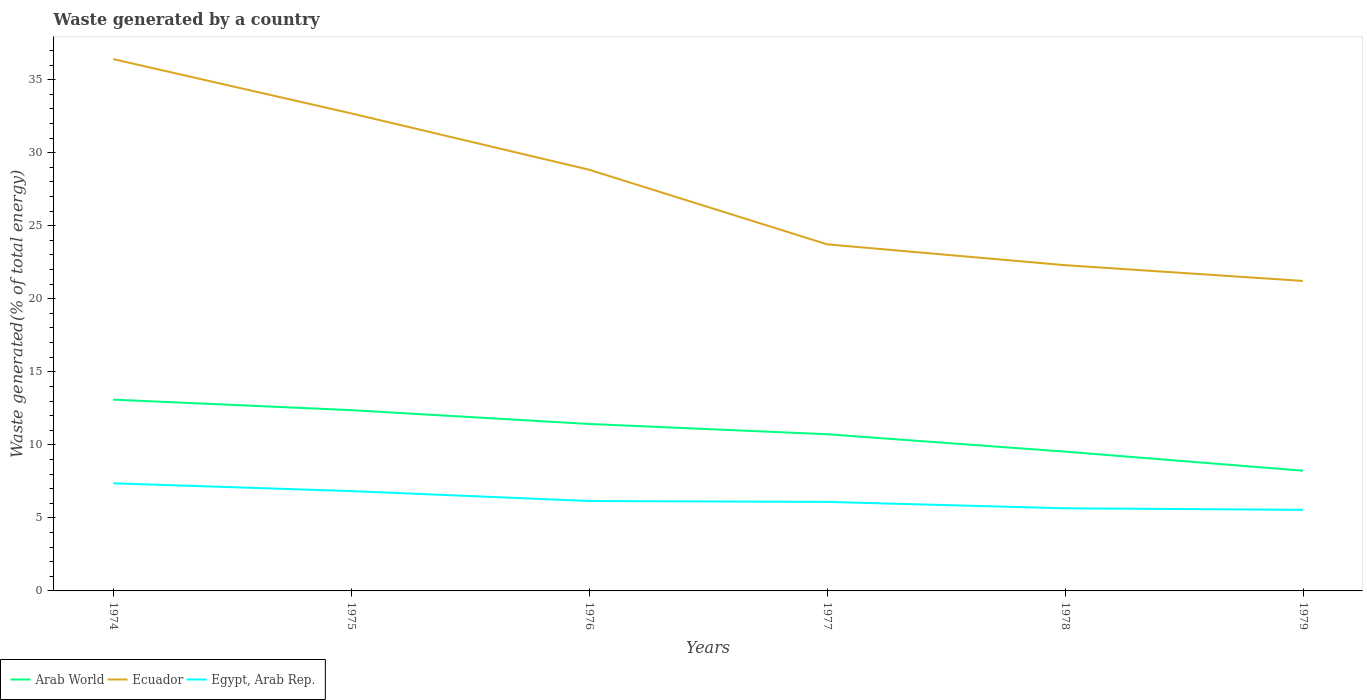Does the line corresponding to Arab World intersect with the line corresponding to Ecuador?
Make the answer very short. No. Across all years, what is the maximum total waste generated in Egypt, Arab Rep.?
Your response must be concise. 5.55. In which year was the total waste generated in Ecuador maximum?
Provide a succinct answer. 1979. What is the total total waste generated in Arab World in the graph?
Make the answer very short. 2.37. What is the difference between the highest and the second highest total waste generated in Ecuador?
Your answer should be very brief. 15.18. How many lines are there?
Keep it short and to the point. 3. How many years are there in the graph?
Ensure brevity in your answer.  6. Are the values on the major ticks of Y-axis written in scientific E-notation?
Offer a terse response. No. Does the graph contain any zero values?
Your answer should be compact. No. Does the graph contain grids?
Your answer should be compact. No. How many legend labels are there?
Offer a very short reply. 3. What is the title of the graph?
Ensure brevity in your answer.  Waste generated by a country. Does "Turkmenistan" appear as one of the legend labels in the graph?
Offer a very short reply. No. What is the label or title of the X-axis?
Your answer should be compact. Years. What is the label or title of the Y-axis?
Offer a very short reply. Waste generated(% of total energy). What is the Waste generated(% of total energy) in Arab World in 1974?
Make the answer very short. 13.09. What is the Waste generated(% of total energy) of Ecuador in 1974?
Make the answer very short. 36.41. What is the Waste generated(% of total energy) of Egypt, Arab Rep. in 1974?
Ensure brevity in your answer.  7.37. What is the Waste generated(% of total energy) of Arab World in 1975?
Make the answer very short. 12.38. What is the Waste generated(% of total energy) of Ecuador in 1975?
Your answer should be very brief. 32.69. What is the Waste generated(% of total energy) of Egypt, Arab Rep. in 1975?
Your answer should be very brief. 6.83. What is the Waste generated(% of total energy) of Arab World in 1976?
Give a very brief answer. 11.43. What is the Waste generated(% of total energy) in Ecuador in 1976?
Your response must be concise. 28.83. What is the Waste generated(% of total energy) in Egypt, Arab Rep. in 1976?
Keep it short and to the point. 6.16. What is the Waste generated(% of total energy) of Arab World in 1977?
Your answer should be compact. 10.73. What is the Waste generated(% of total energy) in Ecuador in 1977?
Your answer should be compact. 23.73. What is the Waste generated(% of total energy) of Egypt, Arab Rep. in 1977?
Your response must be concise. 6.09. What is the Waste generated(% of total energy) of Arab World in 1978?
Keep it short and to the point. 9.54. What is the Waste generated(% of total energy) in Ecuador in 1978?
Your response must be concise. 22.3. What is the Waste generated(% of total energy) of Egypt, Arab Rep. in 1978?
Give a very brief answer. 5.66. What is the Waste generated(% of total energy) of Arab World in 1979?
Your answer should be compact. 8.23. What is the Waste generated(% of total energy) in Ecuador in 1979?
Make the answer very short. 21.22. What is the Waste generated(% of total energy) of Egypt, Arab Rep. in 1979?
Give a very brief answer. 5.55. Across all years, what is the maximum Waste generated(% of total energy) in Arab World?
Provide a short and direct response. 13.09. Across all years, what is the maximum Waste generated(% of total energy) in Ecuador?
Your response must be concise. 36.41. Across all years, what is the maximum Waste generated(% of total energy) in Egypt, Arab Rep.?
Make the answer very short. 7.37. Across all years, what is the minimum Waste generated(% of total energy) of Arab World?
Keep it short and to the point. 8.23. Across all years, what is the minimum Waste generated(% of total energy) of Ecuador?
Give a very brief answer. 21.22. Across all years, what is the minimum Waste generated(% of total energy) in Egypt, Arab Rep.?
Provide a succinct answer. 5.55. What is the total Waste generated(% of total energy) of Arab World in the graph?
Keep it short and to the point. 65.39. What is the total Waste generated(% of total energy) in Ecuador in the graph?
Your response must be concise. 165.18. What is the total Waste generated(% of total energy) of Egypt, Arab Rep. in the graph?
Provide a short and direct response. 37.66. What is the difference between the Waste generated(% of total energy) of Arab World in 1974 and that in 1975?
Offer a terse response. 0.72. What is the difference between the Waste generated(% of total energy) of Ecuador in 1974 and that in 1975?
Keep it short and to the point. 3.71. What is the difference between the Waste generated(% of total energy) in Egypt, Arab Rep. in 1974 and that in 1975?
Your answer should be very brief. 0.53. What is the difference between the Waste generated(% of total energy) of Arab World in 1974 and that in 1976?
Provide a succinct answer. 1.67. What is the difference between the Waste generated(% of total energy) in Ecuador in 1974 and that in 1976?
Provide a succinct answer. 7.57. What is the difference between the Waste generated(% of total energy) in Egypt, Arab Rep. in 1974 and that in 1976?
Give a very brief answer. 1.21. What is the difference between the Waste generated(% of total energy) in Arab World in 1974 and that in 1977?
Offer a very short reply. 2.37. What is the difference between the Waste generated(% of total energy) in Ecuador in 1974 and that in 1977?
Ensure brevity in your answer.  12.68. What is the difference between the Waste generated(% of total energy) of Egypt, Arab Rep. in 1974 and that in 1977?
Your answer should be compact. 1.27. What is the difference between the Waste generated(% of total energy) in Arab World in 1974 and that in 1978?
Your response must be concise. 3.56. What is the difference between the Waste generated(% of total energy) of Ecuador in 1974 and that in 1978?
Provide a succinct answer. 14.11. What is the difference between the Waste generated(% of total energy) in Egypt, Arab Rep. in 1974 and that in 1978?
Offer a terse response. 1.71. What is the difference between the Waste generated(% of total energy) of Arab World in 1974 and that in 1979?
Your answer should be very brief. 4.87. What is the difference between the Waste generated(% of total energy) in Ecuador in 1974 and that in 1979?
Offer a very short reply. 15.18. What is the difference between the Waste generated(% of total energy) in Egypt, Arab Rep. in 1974 and that in 1979?
Offer a terse response. 1.82. What is the difference between the Waste generated(% of total energy) of Arab World in 1975 and that in 1976?
Your answer should be very brief. 0.95. What is the difference between the Waste generated(% of total energy) of Ecuador in 1975 and that in 1976?
Make the answer very short. 3.86. What is the difference between the Waste generated(% of total energy) of Egypt, Arab Rep. in 1975 and that in 1976?
Ensure brevity in your answer.  0.68. What is the difference between the Waste generated(% of total energy) of Arab World in 1975 and that in 1977?
Make the answer very short. 1.65. What is the difference between the Waste generated(% of total energy) of Ecuador in 1975 and that in 1977?
Your answer should be very brief. 8.97. What is the difference between the Waste generated(% of total energy) of Egypt, Arab Rep. in 1975 and that in 1977?
Provide a short and direct response. 0.74. What is the difference between the Waste generated(% of total energy) of Arab World in 1975 and that in 1978?
Make the answer very short. 2.84. What is the difference between the Waste generated(% of total energy) in Ecuador in 1975 and that in 1978?
Your answer should be compact. 10.39. What is the difference between the Waste generated(% of total energy) in Egypt, Arab Rep. in 1975 and that in 1978?
Give a very brief answer. 1.18. What is the difference between the Waste generated(% of total energy) in Arab World in 1975 and that in 1979?
Your answer should be very brief. 4.15. What is the difference between the Waste generated(% of total energy) of Ecuador in 1975 and that in 1979?
Keep it short and to the point. 11.47. What is the difference between the Waste generated(% of total energy) of Egypt, Arab Rep. in 1975 and that in 1979?
Your answer should be compact. 1.28. What is the difference between the Waste generated(% of total energy) in Arab World in 1976 and that in 1977?
Keep it short and to the point. 0.7. What is the difference between the Waste generated(% of total energy) of Ecuador in 1976 and that in 1977?
Give a very brief answer. 5.11. What is the difference between the Waste generated(% of total energy) of Egypt, Arab Rep. in 1976 and that in 1977?
Offer a very short reply. 0.06. What is the difference between the Waste generated(% of total energy) of Arab World in 1976 and that in 1978?
Make the answer very short. 1.89. What is the difference between the Waste generated(% of total energy) of Ecuador in 1976 and that in 1978?
Provide a short and direct response. 6.53. What is the difference between the Waste generated(% of total energy) in Egypt, Arab Rep. in 1976 and that in 1978?
Provide a short and direct response. 0.5. What is the difference between the Waste generated(% of total energy) of Arab World in 1976 and that in 1979?
Give a very brief answer. 3.2. What is the difference between the Waste generated(% of total energy) in Ecuador in 1976 and that in 1979?
Keep it short and to the point. 7.61. What is the difference between the Waste generated(% of total energy) in Egypt, Arab Rep. in 1976 and that in 1979?
Offer a terse response. 0.6. What is the difference between the Waste generated(% of total energy) in Arab World in 1977 and that in 1978?
Offer a terse response. 1.19. What is the difference between the Waste generated(% of total energy) of Ecuador in 1977 and that in 1978?
Offer a terse response. 1.43. What is the difference between the Waste generated(% of total energy) in Egypt, Arab Rep. in 1977 and that in 1978?
Give a very brief answer. 0.44. What is the difference between the Waste generated(% of total energy) in Arab World in 1977 and that in 1979?
Offer a terse response. 2.5. What is the difference between the Waste generated(% of total energy) in Ecuador in 1977 and that in 1979?
Keep it short and to the point. 2.5. What is the difference between the Waste generated(% of total energy) of Egypt, Arab Rep. in 1977 and that in 1979?
Your answer should be very brief. 0.54. What is the difference between the Waste generated(% of total energy) of Arab World in 1978 and that in 1979?
Provide a short and direct response. 1.31. What is the difference between the Waste generated(% of total energy) in Ecuador in 1978 and that in 1979?
Your response must be concise. 1.08. What is the difference between the Waste generated(% of total energy) of Egypt, Arab Rep. in 1978 and that in 1979?
Make the answer very short. 0.1. What is the difference between the Waste generated(% of total energy) of Arab World in 1974 and the Waste generated(% of total energy) of Ecuador in 1975?
Your answer should be compact. -19.6. What is the difference between the Waste generated(% of total energy) in Arab World in 1974 and the Waste generated(% of total energy) in Egypt, Arab Rep. in 1975?
Provide a succinct answer. 6.26. What is the difference between the Waste generated(% of total energy) of Ecuador in 1974 and the Waste generated(% of total energy) of Egypt, Arab Rep. in 1975?
Provide a short and direct response. 29.57. What is the difference between the Waste generated(% of total energy) in Arab World in 1974 and the Waste generated(% of total energy) in Ecuador in 1976?
Your answer should be compact. -15.74. What is the difference between the Waste generated(% of total energy) in Arab World in 1974 and the Waste generated(% of total energy) in Egypt, Arab Rep. in 1976?
Keep it short and to the point. 6.94. What is the difference between the Waste generated(% of total energy) of Ecuador in 1974 and the Waste generated(% of total energy) of Egypt, Arab Rep. in 1976?
Provide a short and direct response. 30.25. What is the difference between the Waste generated(% of total energy) of Arab World in 1974 and the Waste generated(% of total energy) of Ecuador in 1977?
Keep it short and to the point. -10.63. What is the difference between the Waste generated(% of total energy) in Arab World in 1974 and the Waste generated(% of total energy) in Egypt, Arab Rep. in 1977?
Your answer should be very brief. 7. What is the difference between the Waste generated(% of total energy) of Ecuador in 1974 and the Waste generated(% of total energy) of Egypt, Arab Rep. in 1977?
Make the answer very short. 30.31. What is the difference between the Waste generated(% of total energy) in Arab World in 1974 and the Waste generated(% of total energy) in Ecuador in 1978?
Provide a short and direct response. -9.21. What is the difference between the Waste generated(% of total energy) in Arab World in 1974 and the Waste generated(% of total energy) in Egypt, Arab Rep. in 1978?
Make the answer very short. 7.44. What is the difference between the Waste generated(% of total energy) of Ecuador in 1974 and the Waste generated(% of total energy) of Egypt, Arab Rep. in 1978?
Provide a succinct answer. 30.75. What is the difference between the Waste generated(% of total energy) in Arab World in 1974 and the Waste generated(% of total energy) in Ecuador in 1979?
Your response must be concise. -8.13. What is the difference between the Waste generated(% of total energy) of Arab World in 1974 and the Waste generated(% of total energy) of Egypt, Arab Rep. in 1979?
Offer a very short reply. 7.54. What is the difference between the Waste generated(% of total energy) of Ecuador in 1974 and the Waste generated(% of total energy) of Egypt, Arab Rep. in 1979?
Keep it short and to the point. 30.86. What is the difference between the Waste generated(% of total energy) in Arab World in 1975 and the Waste generated(% of total energy) in Ecuador in 1976?
Your response must be concise. -16.46. What is the difference between the Waste generated(% of total energy) of Arab World in 1975 and the Waste generated(% of total energy) of Egypt, Arab Rep. in 1976?
Provide a succinct answer. 6.22. What is the difference between the Waste generated(% of total energy) in Ecuador in 1975 and the Waste generated(% of total energy) in Egypt, Arab Rep. in 1976?
Offer a terse response. 26.54. What is the difference between the Waste generated(% of total energy) in Arab World in 1975 and the Waste generated(% of total energy) in Ecuador in 1977?
Offer a terse response. -11.35. What is the difference between the Waste generated(% of total energy) of Arab World in 1975 and the Waste generated(% of total energy) of Egypt, Arab Rep. in 1977?
Your answer should be compact. 6.28. What is the difference between the Waste generated(% of total energy) of Ecuador in 1975 and the Waste generated(% of total energy) of Egypt, Arab Rep. in 1977?
Ensure brevity in your answer.  26.6. What is the difference between the Waste generated(% of total energy) in Arab World in 1975 and the Waste generated(% of total energy) in Ecuador in 1978?
Your answer should be compact. -9.92. What is the difference between the Waste generated(% of total energy) of Arab World in 1975 and the Waste generated(% of total energy) of Egypt, Arab Rep. in 1978?
Offer a very short reply. 6.72. What is the difference between the Waste generated(% of total energy) in Ecuador in 1975 and the Waste generated(% of total energy) in Egypt, Arab Rep. in 1978?
Give a very brief answer. 27.04. What is the difference between the Waste generated(% of total energy) of Arab World in 1975 and the Waste generated(% of total energy) of Ecuador in 1979?
Your answer should be very brief. -8.85. What is the difference between the Waste generated(% of total energy) of Arab World in 1975 and the Waste generated(% of total energy) of Egypt, Arab Rep. in 1979?
Keep it short and to the point. 6.82. What is the difference between the Waste generated(% of total energy) in Ecuador in 1975 and the Waste generated(% of total energy) in Egypt, Arab Rep. in 1979?
Offer a terse response. 27.14. What is the difference between the Waste generated(% of total energy) of Arab World in 1976 and the Waste generated(% of total energy) of Ecuador in 1977?
Offer a terse response. -12.3. What is the difference between the Waste generated(% of total energy) of Arab World in 1976 and the Waste generated(% of total energy) of Egypt, Arab Rep. in 1977?
Your answer should be very brief. 5.33. What is the difference between the Waste generated(% of total energy) of Ecuador in 1976 and the Waste generated(% of total energy) of Egypt, Arab Rep. in 1977?
Your answer should be very brief. 22.74. What is the difference between the Waste generated(% of total energy) in Arab World in 1976 and the Waste generated(% of total energy) in Ecuador in 1978?
Provide a succinct answer. -10.87. What is the difference between the Waste generated(% of total energy) of Arab World in 1976 and the Waste generated(% of total energy) of Egypt, Arab Rep. in 1978?
Make the answer very short. 5.77. What is the difference between the Waste generated(% of total energy) of Ecuador in 1976 and the Waste generated(% of total energy) of Egypt, Arab Rep. in 1978?
Ensure brevity in your answer.  23.18. What is the difference between the Waste generated(% of total energy) of Arab World in 1976 and the Waste generated(% of total energy) of Ecuador in 1979?
Your answer should be very brief. -9.79. What is the difference between the Waste generated(% of total energy) of Arab World in 1976 and the Waste generated(% of total energy) of Egypt, Arab Rep. in 1979?
Ensure brevity in your answer.  5.88. What is the difference between the Waste generated(% of total energy) of Ecuador in 1976 and the Waste generated(% of total energy) of Egypt, Arab Rep. in 1979?
Your answer should be compact. 23.28. What is the difference between the Waste generated(% of total energy) of Arab World in 1977 and the Waste generated(% of total energy) of Ecuador in 1978?
Keep it short and to the point. -11.57. What is the difference between the Waste generated(% of total energy) of Arab World in 1977 and the Waste generated(% of total energy) of Egypt, Arab Rep. in 1978?
Keep it short and to the point. 5.07. What is the difference between the Waste generated(% of total energy) of Ecuador in 1977 and the Waste generated(% of total energy) of Egypt, Arab Rep. in 1978?
Ensure brevity in your answer.  18.07. What is the difference between the Waste generated(% of total energy) of Arab World in 1977 and the Waste generated(% of total energy) of Ecuador in 1979?
Keep it short and to the point. -10.5. What is the difference between the Waste generated(% of total energy) of Arab World in 1977 and the Waste generated(% of total energy) of Egypt, Arab Rep. in 1979?
Your answer should be very brief. 5.18. What is the difference between the Waste generated(% of total energy) of Ecuador in 1977 and the Waste generated(% of total energy) of Egypt, Arab Rep. in 1979?
Offer a very short reply. 18.18. What is the difference between the Waste generated(% of total energy) of Arab World in 1978 and the Waste generated(% of total energy) of Ecuador in 1979?
Ensure brevity in your answer.  -11.69. What is the difference between the Waste generated(% of total energy) of Arab World in 1978 and the Waste generated(% of total energy) of Egypt, Arab Rep. in 1979?
Offer a very short reply. 3.98. What is the difference between the Waste generated(% of total energy) in Ecuador in 1978 and the Waste generated(% of total energy) in Egypt, Arab Rep. in 1979?
Provide a short and direct response. 16.75. What is the average Waste generated(% of total energy) in Arab World per year?
Make the answer very short. 10.9. What is the average Waste generated(% of total energy) in Ecuador per year?
Offer a very short reply. 27.53. What is the average Waste generated(% of total energy) of Egypt, Arab Rep. per year?
Ensure brevity in your answer.  6.28. In the year 1974, what is the difference between the Waste generated(% of total energy) of Arab World and Waste generated(% of total energy) of Ecuador?
Give a very brief answer. -23.31. In the year 1974, what is the difference between the Waste generated(% of total energy) of Arab World and Waste generated(% of total energy) of Egypt, Arab Rep.?
Offer a very short reply. 5.73. In the year 1974, what is the difference between the Waste generated(% of total energy) in Ecuador and Waste generated(% of total energy) in Egypt, Arab Rep.?
Make the answer very short. 29.04. In the year 1975, what is the difference between the Waste generated(% of total energy) in Arab World and Waste generated(% of total energy) in Ecuador?
Provide a succinct answer. -20.32. In the year 1975, what is the difference between the Waste generated(% of total energy) in Arab World and Waste generated(% of total energy) in Egypt, Arab Rep.?
Offer a terse response. 5.54. In the year 1975, what is the difference between the Waste generated(% of total energy) of Ecuador and Waste generated(% of total energy) of Egypt, Arab Rep.?
Provide a short and direct response. 25.86. In the year 1976, what is the difference between the Waste generated(% of total energy) of Arab World and Waste generated(% of total energy) of Ecuador?
Keep it short and to the point. -17.41. In the year 1976, what is the difference between the Waste generated(% of total energy) of Arab World and Waste generated(% of total energy) of Egypt, Arab Rep.?
Your answer should be compact. 5.27. In the year 1976, what is the difference between the Waste generated(% of total energy) of Ecuador and Waste generated(% of total energy) of Egypt, Arab Rep.?
Provide a succinct answer. 22.68. In the year 1977, what is the difference between the Waste generated(% of total energy) of Arab World and Waste generated(% of total energy) of Ecuador?
Your answer should be compact. -13. In the year 1977, what is the difference between the Waste generated(% of total energy) of Arab World and Waste generated(% of total energy) of Egypt, Arab Rep.?
Make the answer very short. 4.63. In the year 1977, what is the difference between the Waste generated(% of total energy) of Ecuador and Waste generated(% of total energy) of Egypt, Arab Rep.?
Your response must be concise. 17.63. In the year 1978, what is the difference between the Waste generated(% of total energy) in Arab World and Waste generated(% of total energy) in Ecuador?
Offer a terse response. -12.76. In the year 1978, what is the difference between the Waste generated(% of total energy) of Arab World and Waste generated(% of total energy) of Egypt, Arab Rep.?
Your answer should be compact. 3.88. In the year 1978, what is the difference between the Waste generated(% of total energy) in Ecuador and Waste generated(% of total energy) in Egypt, Arab Rep.?
Keep it short and to the point. 16.64. In the year 1979, what is the difference between the Waste generated(% of total energy) of Arab World and Waste generated(% of total energy) of Ecuador?
Offer a terse response. -12.99. In the year 1979, what is the difference between the Waste generated(% of total energy) of Arab World and Waste generated(% of total energy) of Egypt, Arab Rep.?
Offer a very short reply. 2.68. In the year 1979, what is the difference between the Waste generated(% of total energy) of Ecuador and Waste generated(% of total energy) of Egypt, Arab Rep.?
Ensure brevity in your answer.  15.67. What is the ratio of the Waste generated(% of total energy) of Arab World in 1974 to that in 1975?
Your answer should be very brief. 1.06. What is the ratio of the Waste generated(% of total energy) of Ecuador in 1974 to that in 1975?
Your answer should be compact. 1.11. What is the ratio of the Waste generated(% of total energy) in Egypt, Arab Rep. in 1974 to that in 1975?
Provide a succinct answer. 1.08. What is the ratio of the Waste generated(% of total energy) in Arab World in 1974 to that in 1976?
Offer a terse response. 1.15. What is the ratio of the Waste generated(% of total energy) of Ecuador in 1974 to that in 1976?
Provide a short and direct response. 1.26. What is the ratio of the Waste generated(% of total energy) of Egypt, Arab Rep. in 1974 to that in 1976?
Offer a very short reply. 1.2. What is the ratio of the Waste generated(% of total energy) of Arab World in 1974 to that in 1977?
Your answer should be compact. 1.22. What is the ratio of the Waste generated(% of total energy) in Ecuador in 1974 to that in 1977?
Your answer should be very brief. 1.53. What is the ratio of the Waste generated(% of total energy) of Egypt, Arab Rep. in 1974 to that in 1977?
Your response must be concise. 1.21. What is the ratio of the Waste generated(% of total energy) of Arab World in 1974 to that in 1978?
Your response must be concise. 1.37. What is the ratio of the Waste generated(% of total energy) in Ecuador in 1974 to that in 1978?
Ensure brevity in your answer.  1.63. What is the ratio of the Waste generated(% of total energy) of Egypt, Arab Rep. in 1974 to that in 1978?
Ensure brevity in your answer.  1.3. What is the ratio of the Waste generated(% of total energy) of Arab World in 1974 to that in 1979?
Offer a very short reply. 1.59. What is the ratio of the Waste generated(% of total energy) of Ecuador in 1974 to that in 1979?
Your answer should be compact. 1.72. What is the ratio of the Waste generated(% of total energy) in Egypt, Arab Rep. in 1974 to that in 1979?
Make the answer very short. 1.33. What is the ratio of the Waste generated(% of total energy) in Arab World in 1975 to that in 1976?
Provide a succinct answer. 1.08. What is the ratio of the Waste generated(% of total energy) of Ecuador in 1975 to that in 1976?
Your answer should be very brief. 1.13. What is the ratio of the Waste generated(% of total energy) of Egypt, Arab Rep. in 1975 to that in 1976?
Provide a succinct answer. 1.11. What is the ratio of the Waste generated(% of total energy) of Arab World in 1975 to that in 1977?
Ensure brevity in your answer.  1.15. What is the ratio of the Waste generated(% of total energy) of Ecuador in 1975 to that in 1977?
Provide a short and direct response. 1.38. What is the ratio of the Waste generated(% of total energy) in Egypt, Arab Rep. in 1975 to that in 1977?
Ensure brevity in your answer.  1.12. What is the ratio of the Waste generated(% of total energy) of Arab World in 1975 to that in 1978?
Provide a succinct answer. 1.3. What is the ratio of the Waste generated(% of total energy) in Ecuador in 1975 to that in 1978?
Give a very brief answer. 1.47. What is the ratio of the Waste generated(% of total energy) in Egypt, Arab Rep. in 1975 to that in 1978?
Provide a short and direct response. 1.21. What is the ratio of the Waste generated(% of total energy) of Arab World in 1975 to that in 1979?
Provide a succinct answer. 1.5. What is the ratio of the Waste generated(% of total energy) in Ecuador in 1975 to that in 1979?
Make the answer very short. 1.54. What is the ratio of the Waste generated(% of total energy) of Egypt, Arab Rep. in 1975 to that in 1979?
Give a very brief answer. 1.23. What is the ratio of the Waste generated(% of total energy) of Arab World in 1976 to that in 1977?
Your answer should be very brief. 1.07. What is the ratio of the Waste generated(% of total energy) in Ecuador in 1976 to that in 1977?
Ensure brevity in your answer.  1.22. What is the ratio of the Waste generated(% of total energy) of Egypt, Arab Rep. in 1976 to that in 1977?
Offer a very short reply. 1.01. What is the ratio of the Waste generated(% of total energy) of Arab World in 1976 to that in 1978?
Provide a succinct answer. 1.2. What is the ratio of the Waste generated(% of total energy) in Ecuador in 1976 to that in 1978?
Your answer should be very brief. 1.29. What is the ratio of the Waste generated(% of total energy) in Egypt, Arab Rep. in 1976 to that in 1978?
Provide a succinct answer. 1.09. What is the ratio of the Waste generated(% of total energy) in Arab World in 1976 to that in 1979?
Your response must be concise. 1.39. What is the ratio of the Waste generated(% of total energy) of Ecuador in 1976 to that in 1979?
Offer a very short reply. 1.36. What is the ratio of the Waste generated(% of total energy) of Egypt, Arab Rep. in 1976 to that in 1979?
Ensure brevity in your answer.  1.11. What is the ratio of the Waste generated(% of total energy) of Arab World in 1977 to that in 1978?
Give a very brief answer. 1.12. What is the ratio of the Waste generated(% of total energy) in Ecuador in 1977 to that in 1978?
Your answer should be compact. 1.06. What is the ratio of the Waste generated(% of total energy) in Egypt, Arab Rep. in 1977 to that in 1978?
Ensure brevity in your answer.  1.08. What is the ratio of the Waste generated(% of total energy) of Arab World in 1977 to that in 1979?
Make the answer very short. 1.3. What is the ratio of the Waste generated(% of total energy) of Ecuador in 1977 to that in 1979?
Offer a very short reply. 1.12. What is the ratio of the Waste generated(% of total energy) in Egypt, Arab Rep. in 1977 to that in 1979?
Ensure brevity in your answer.  1.1. What is the ratio of the Waste generated(% of total energy) in Arab World in 1978 to that in 1979?
Provide a short and direct response. 1.16. What is the ratio of the Waste generated(% of total energy) of Ecuador in 1978 to that in 1979?
Keep it short and to the point. 1.05. What is the ratio of the Waste generated(% of total energy) of Egypt, Arab Rep. in 1978 to that in 1979?
Provide a short and direct response. 1.02. What is the difference between the highest and the second highest Waste generated(% of total energy) of Arab World?
Your answer should be compact. 0.72. What is the difference between the highest and the second highest Waste generated(% of total energy) of Ecuador?
Ensure brevity in your answer.  3.71. What is the difference between the highest and the second highest Waste generated(% of total energy) of Egypt, Arab Rep.?
Make the answer very short. 0.53. What is the difference between the highest and the lowest Waste generated(% of total energy) of Arab World?
Give a very brief answer. 4.87. What is the difference between the highest and the lowest Waste generated(% of total energy) of Ecuador?
Make the answer very short. 15.18. What is the difference between the highest and the lowest Waste generated(% of total energy) in Egypt, Arab Rep.?
Ensure brevity in your answer.  1.82. 